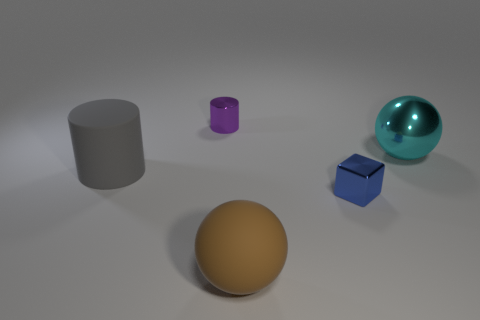How many objects are either tiny metal things left of the blue block or big purple matte balls?
Keep it short and to the point. 1. Are there more cylinders that are to the left of the tiny cylinder than rubber balls that are on the left side of the big rubber cylinder?
Offer a terse response. Yes. Does the blue block have the same material as the large gray cylinder?
Provide a succinct answer. No. What is the shape of the shiny thing that is both on the left side of the large shiny sphere and in front of the small purple thing?
Give a very brief answer. Cube. What shape is the purple object that is made of the same material as the tiny blue cube?
Your response must be concise. Cylinder. Is there a large blue rubber thing?
Offer a terse response. No. Are there any large gray cylinders that are right of the big sphere that is in front of the big cyan object?
Provide a succinct answer. No. What is the material of the brown object that is the same shape as the cyan shiny thing?
Give a very brief answer. Rubber. Is the number of purple metallic objects greater than the number of tiny metallic objects?
Offer a terse response. No. There is a metallic sphere; is it the same color as the small metal thing that is in front of the purple metal thing?
Make the answer very short. No. 